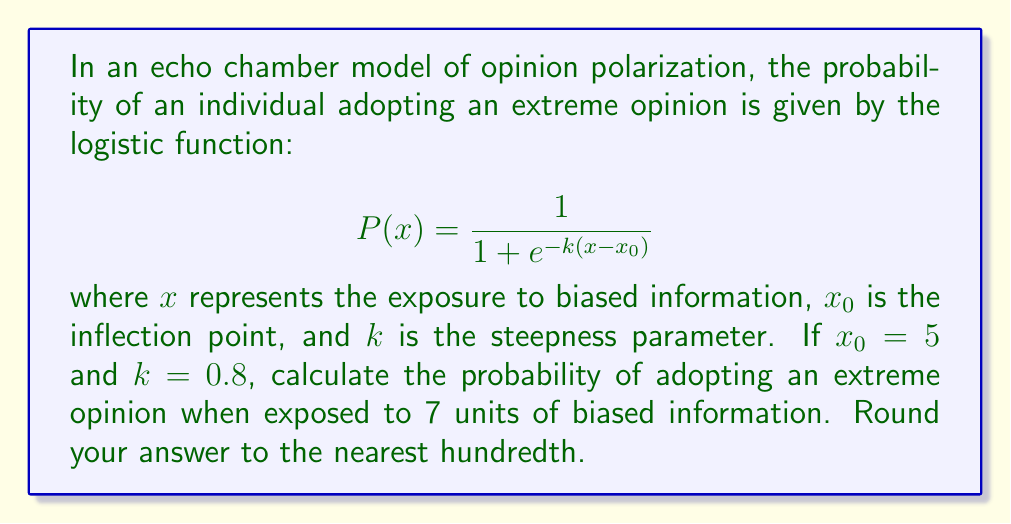Teach me how to tackle this problem. To solve this problem, we'll follow these steps:

1. Identify the given values:
   $x = 7$ (exposure to biased information)
   $x_0 = 5$ (inflection point)
   $k = 0.8$ (steepness parameter)

2. Substitute these values into the logistic function:
   $$P(7) = \frac{1}{1 + e^{-0.8(7-5)}}$$

3. Simplify the expression inside the exponential:
   $$P(7) = \frac{1}{1 + e^{-0.8(2)}} = \frac{1}{1 + e^{-1.6}}$$

4. Calculate the value of $e^{-1.6}$:
   $e^{-1.6} \approx 0.2019$

5. Substitute this value back into the equation:
   $$P(7) = \frac{1}{1 + 0.2019} = \frac{1}{1.2019}$$

6. Perform the division:
   $P(7) \approx 0.8320$

7. Round to the nearest hundredth:
   $P(7) \approx 0.83$
Answer: 0.83 